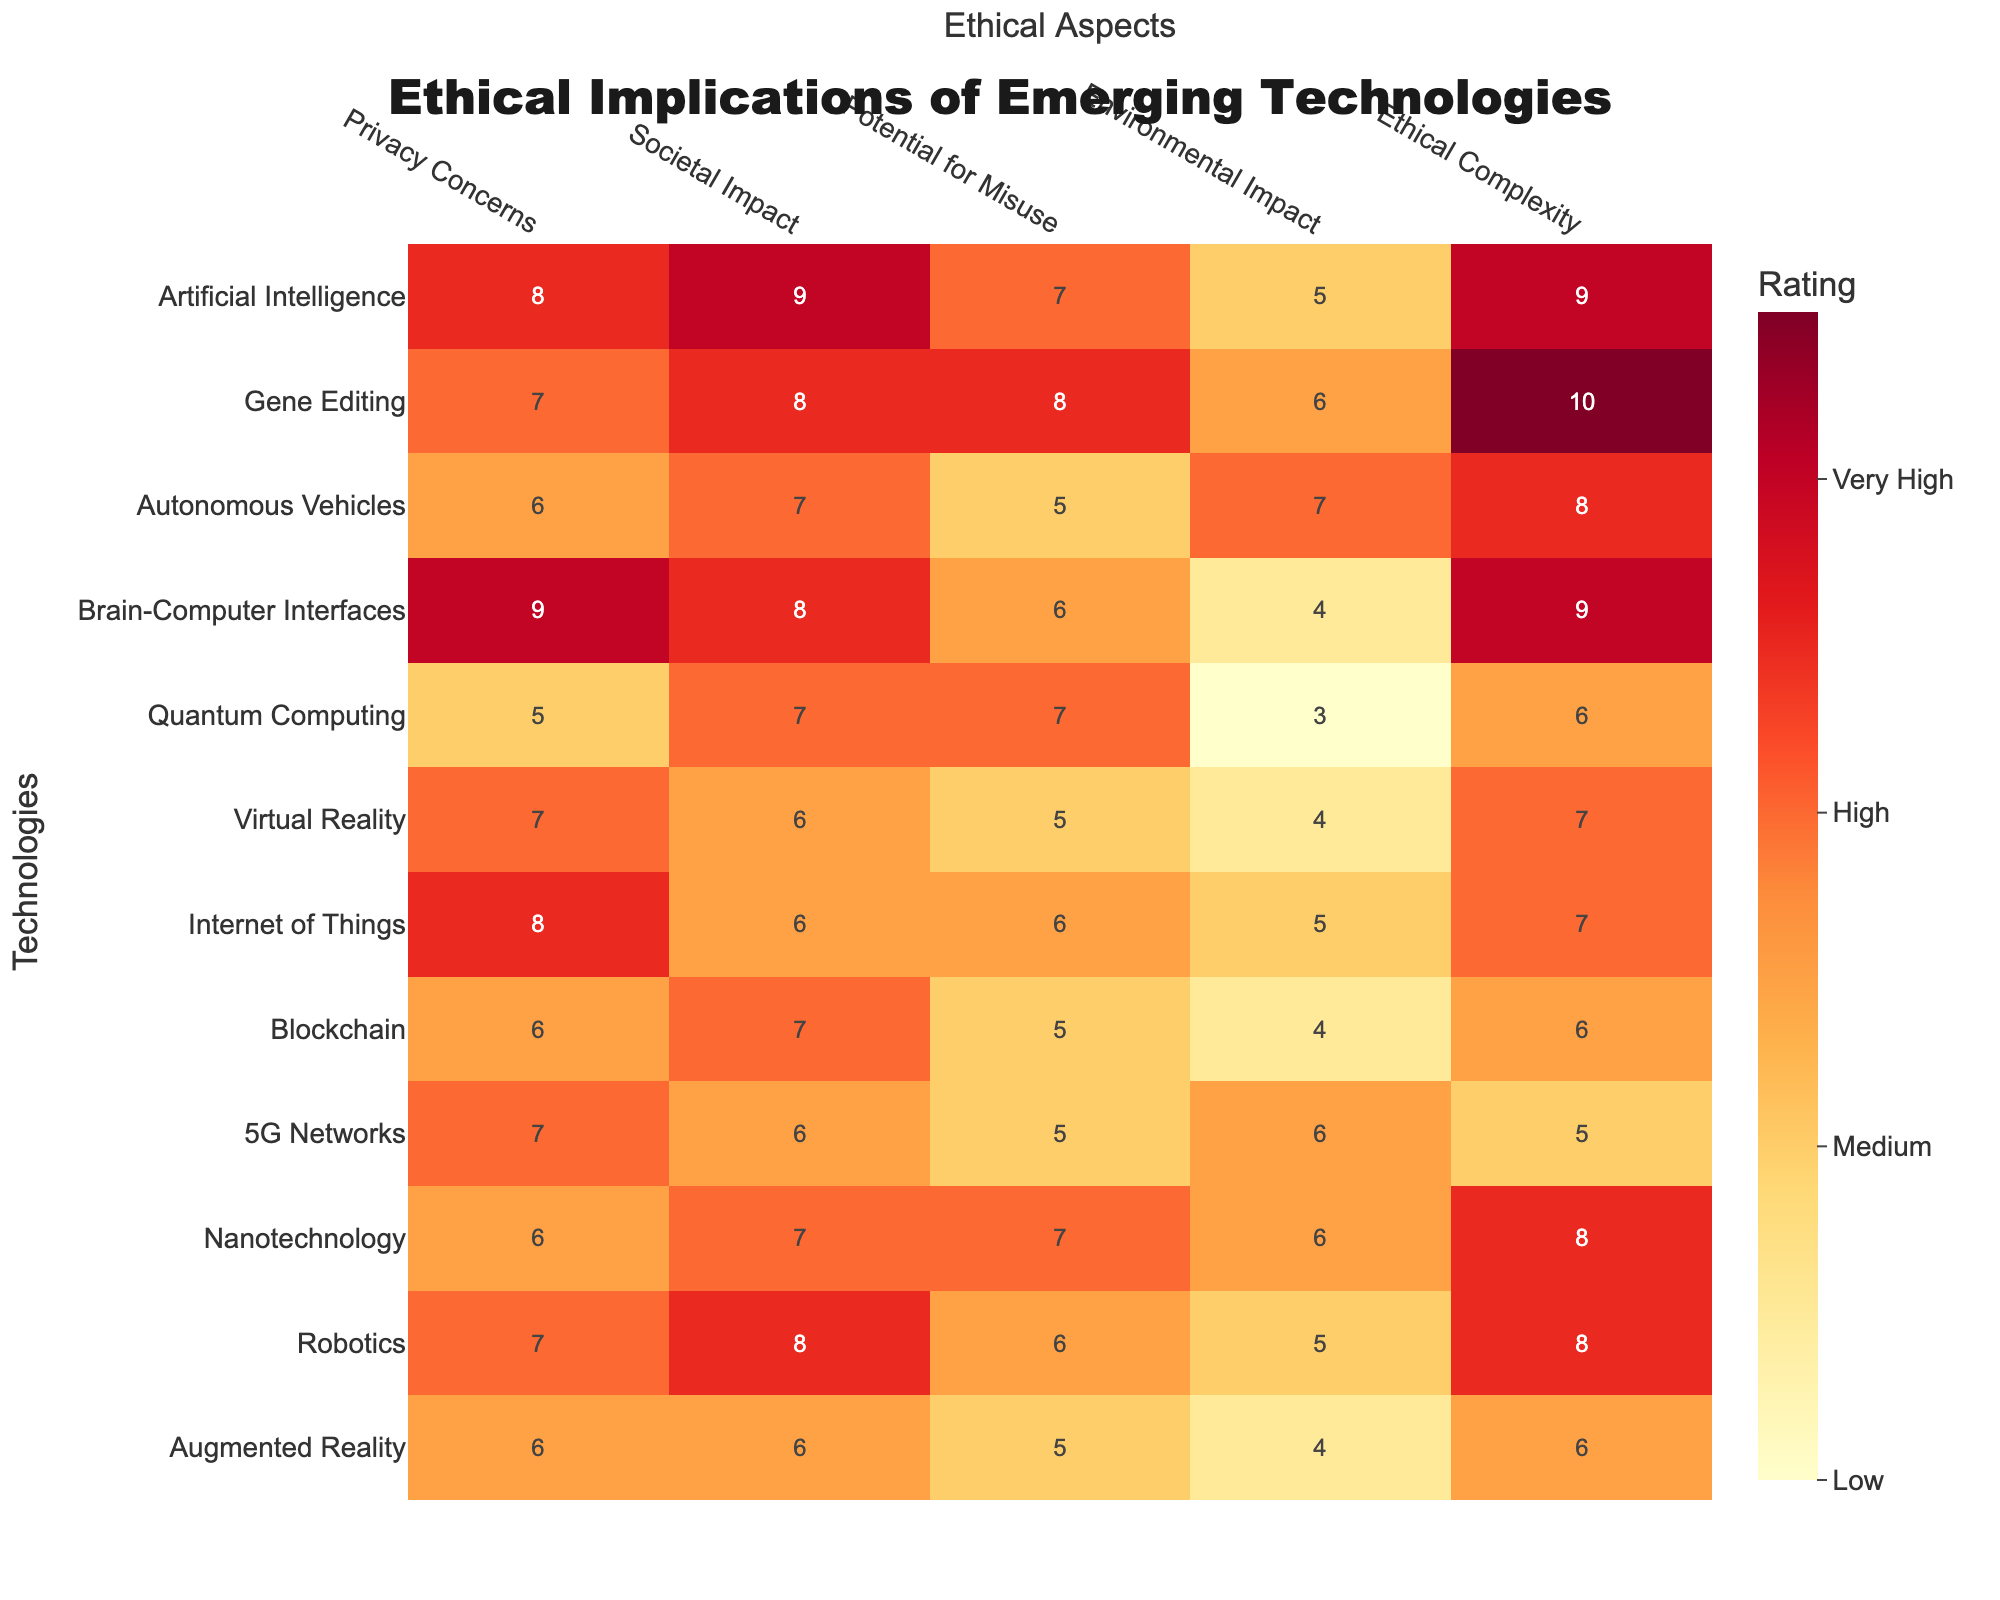What is the highest rating for Privacy Concerns among the technologies? The highest rating for Privacy Concerns is 9, which occurs for Artificial Intelligence and Brain-Computer Interfaces.
Answer: 9 Which technology has the lowest Environmental Impact rating? The lowest Environmental Impact rating is 3, assigned to Quantum Computing.
Answer: 3 What is the average rating for Potential for Misuse across all technologies? Summing the ratings for Potential for Misuse (7 + 8 + 5 + 6 + 7 + 5 + 6 + 5 + 5 + 7 + 6) gives 61. There are 12 technologies, so the average is 61/12 = 5.08.
Answer: 5.08 Is Gene Editing more ethically complex than Artificial Intelligence? Gene Editing has an Ethical Complexity rating of 10 while Artificial Intelligence has 9, thus it is more ethically complex.
Answer: Yes What is the difference in ratings for Societal Impact between Autonomous Vehicles and Virtual Reality? Autonomous Vehicles have a rating of 7, while Virtual Reality has a rating of 6. The difference is 7 - 6 = 1.
Answer: 1 How many technologies have a Privacy Concern rating of 8 or higher? The technologies with a rating of 8 or higher for Privacy Concerns are Artificial Intelligence, Brain-Computer Interfaces, and Internet of Things. That's a total of 3 technologies.
Answer: 3 Which technology has the highest rating for Ethical Complexity, and how does it compare to the second highest? Gene Editing has the highest rating for Ethical Complexity at 10. The second highest is Artificial Intelligence with a rating of 9. The difference is 10 - 9 = 1.
Answer: Gene Editing (10), compared to second highest (1 difference) What is the total rating for Environmental Impact across all technologies? Summing the Environmental Impact ratings (5 + 6 + 7 + 4 + 3 + 4 + 5 + 4 + 6 + 6 + 5 + 4) gives a total of 57.
Answer: 57 Which technology has more Privacy Concerns than Autonomous Vehicles? Autonomous Vehicles have a Privacy Concerns rating of 6. Technologies with higher ratings include Artificial Intelligence (8), Gene Editing (7), Brain-Computer Interfaces (9), and Internet of Things (8). That's a total of 4 technologies.
Answer: 4 